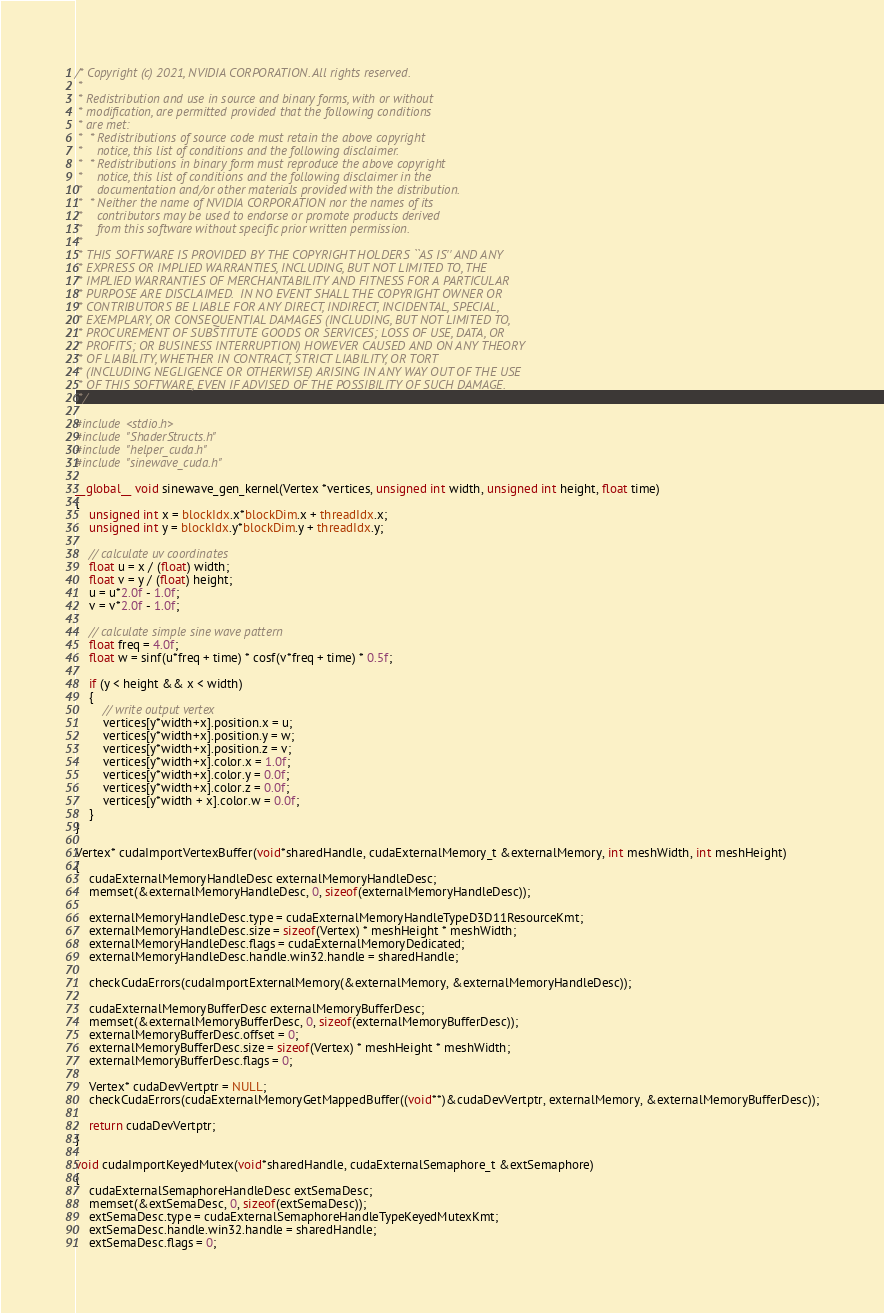Convert code to text. <code><loc_0><loc_0><loc_500><loc_500><_Cuda_>/* Copyright (c) 2021, NVIDIA CORPORATION. All rights reserved.
 *
 * Redistribution and use in source and binary forms, with or without
 * modification, are permitted provided that the following conditions
 * are met:
 *  * Redistributions of source code must retain the above copyright
 *    notice, this list of conditions and the following disclaimer.
 *  * Redistributions in binary form must reproduce the above copyright
 *    notice, this list of conditions and the following disclaimer in the
 *    documentation and/or other materials provided with the distribution.
 *  * Neither the name of NVIDIA CORPORATION nor the names of its
 *    contributors may be used to endorse or promote products derived
 *    from this software without specific prior written permission.
 *
 * THIS SOFTWARE IS PROVIDED BY THE COPYRIGHT HOLDERS ``AS IS'' AND ANY
 * EXPRESS OR IMPLIED WARRANTIES, INCLUDING, BUT NOT LIMITED TO, THE
 * IMPLIED WARRANTIES OF MERCHANTABILITY AND FITNESS FOR A PARTICULAR
 * PURPOSE ARE DISCLAIMED.  IN NO EVENT SHALL THE COPYRIGHT OWNER OR
 * CONTRIBUTORS BE LIABLE FOR ANY DIRECT, INDIRECT, INCIDENTAL, SPECIAL,
 * EXEMPLARY, OR CONSEQUENTIAL DAMAGES (INCLUDING, BUT NOT LIMITED TO,
 * PROCUREMENT OF SUBSTITUTE GOODS OR SERVICES; LOSS OF USE, DATA, OR
 * PROFITS; OR BUSINESS INTERRUPTION) HOWEVER CAUSED AND ON ANY THEORY
 * OF LIABILITY, WHETHER IN CONTRACT, STRICT LIABILITY, OR TORT
 * (INCLUDING NEGLIGENCE OR OTHERWISE) ARISING IN ANY WAY OUT OF THE USE
 * OF THIS SOFTWARE, EVEN IF ADVISED OF THE POSSIBILITY OF SUCH DAMAGE.
 */

#include <stdio.h>
#include "ShaderStructs.h"
#include "helper_cuda.h"
#include "sinewave_cuda.h"

__global__ void sinewave_gen_kernel(Vertex *vertices, unsigned int width, unsigned int height, float time)
{
    unsigned int x = blockIdx.x*blockDim.x + threadIdx.x;
    unsigned int y = blockIdx.y*blockDim.y + threadIdx.y;

    // calculate uv coordinates
    float u = x / (float) width;
    float v = y / (float) height;
    u = u*2.0f - 1.0f;
    v = v*2.0f - 1.0f;

    // calculate simple sine wave pattern
    float freq = 4.0f;
    float w = sinf(u*freq + time) * cosf(v*freq + time) * 0.5f;

    if (y < height && x < width)
    {
        // write output vertex
        vertices[y*width+x].position.x = u;
        vertices[y*width+x].position.y = w;
        vertices[y*width+x].position.z = v;
        vertices[y*width+x].color.x = 1.0f;
        vertices[y*width+x].color.y = 0.0f;
        vertices[y*width+x].color.z = 0.0f;
        vertices[y*width + x].color.w = 0.0f;
    }
}

Vertex* cudaImportVertexBuffer(void*sharedHandle, cudaExternalMemory_t &externalMemory, int meshWidth, int meshHeight)
{
    cudaExternalMemoryHandleDesc externalMemoryHandleDesc;
    memset(&externalMemoryHandleDesc, 0, sizeof(externalMemoryHandleDesc));

    externalMemoryHandleDesc.type = cudaExternalMemoryHandleTypeD3D11ResourceKmt;
    externalMemoryHandleDesc.size = sizeof(Vertex) * meshHeight * meshWidth;
    externalMemoryHandleDesc.flags = cudaExternalMemoryDedicated;
    externalMemoryHandleDesc.handle.win32.handle = sharedHandle;

    checkCudaErrors(cudaImportExternalMemory(&externalMemory, &externalMemoryHandleDesc));

    cudaExternalMemoryBufferDesc externalMemoryBufferDesc;
    memset(&externalMemoryBufferDesc, 0, sizeof(externalMemoryBufferDesc));
    externalMemoryBufferDesc.offset = 0;
    externalMemoryBufferDesc.size = sizeof(Vertex) * meshHeight * meshWidth;
    externalMemoryBufferDesc.flags = 0;

    Vertex* cudaDevVertptr = NULL;
    checkCudaErrors(cudaExternalMemoryGetMappedBuffer((void**)&cudaDevVertptr, externalMemory, &externalMemoryBufferDesc));

    return cudaDevVertptr;
}

void cudaImportKeyedMutex(void*sharedHandle, cudaExternalSemaphore_t &extSemaphore)
{
    cudaExternalSemaphoreHandleDesc extSemaDesc;
    memset(&extSemaDesc, 0, sizeof(extSemaDesc));
    extSemaDesc.type = cudaExternalSemaphoreHandleTypeKeyedMutexKmt;
    extSemaDesc.handle.win32.handle = sharedHandle;
    extSemaDesc.flags = 0;
</code> 